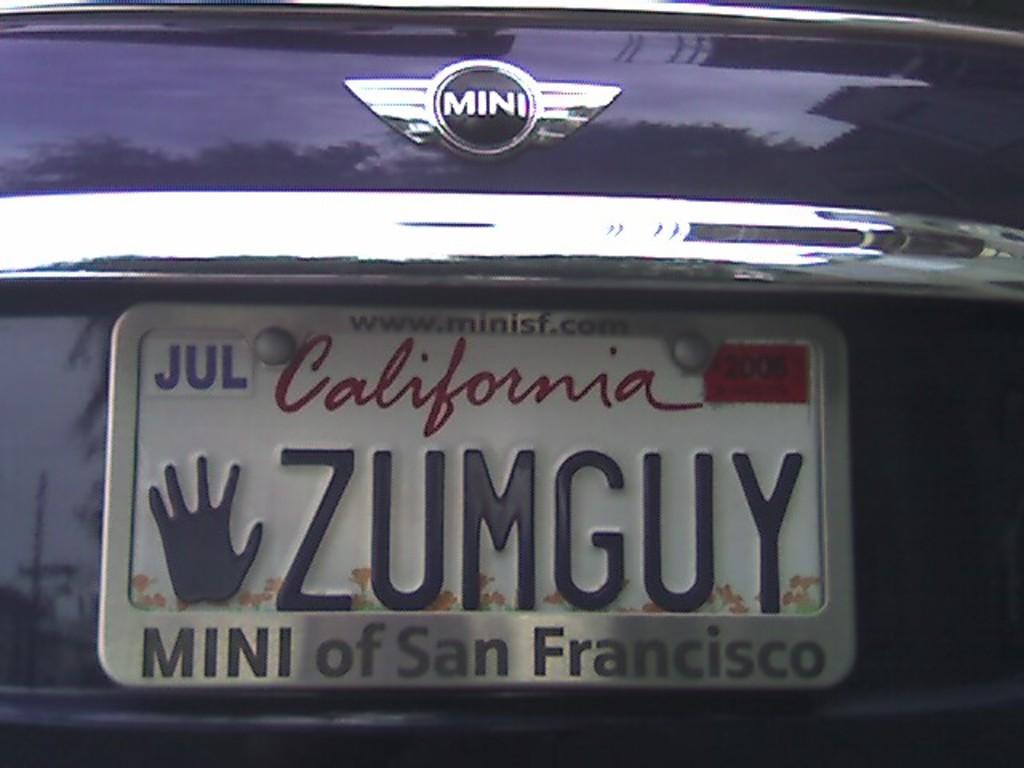<image>
Render a clear and concise summary of the photo. a California license plate on a car with a hand logo as well 